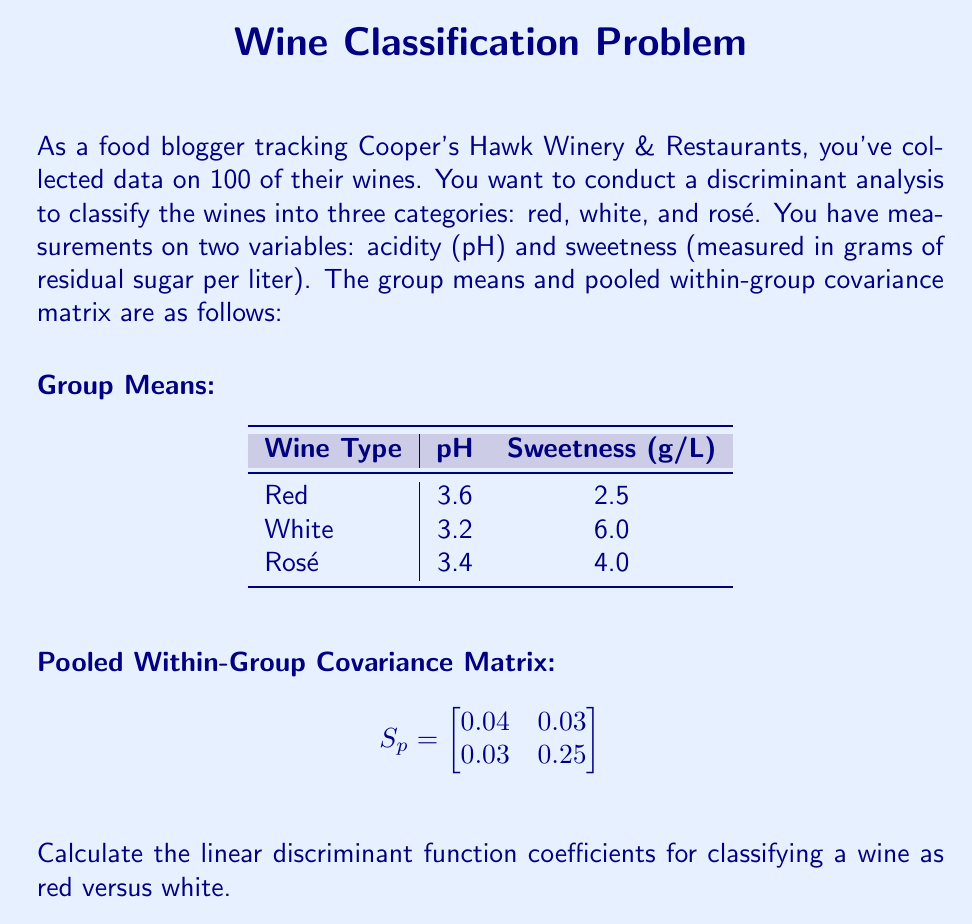Help me with this question. To calculate the linear discriminant function coefficients for red versus white wines, we'll follow these steps:

1) The linear discriminant function has the form:
   $$L = a_1X_1 + a_2X_2 + c$$
   where $X_1$ is pH and $X_2$ is sweetness.

2) The coefficient vector $\mathbf{a} = (a_1, a_2)$ is calculated as:
   $$\mathbf{a} = S_p^{-1}(\bar{\mathbf{x}}_1 - \bar{\mathbf{x}}_2)$$
   where $\bar{\mathbf{x}}_1$ and $\bar{\mathbf{x}}_2$ are the mean vectors for red and white wines respectively.

3) First, let's find $S_p^{-1}$:
   $$S_p^{-1} = \frac{1}{0.04 \cdot 0.25 - 0.03 \cdot 0.03} \begin{bmatrix}
   0.25 & -0.03 \\
   -0.03 & 0.04
   \end{bmatrix} = \begin{bmatrix}
   25.64 & -3.08 \\
   -3.08 & 4.10
   \end{bmatrix}$$

4) Now, let's calculate $(\bar{\mathbf{x}}_1 - \bar{\mathbf{x}}_2)$:
   $$\bar{\mathbf{x}}_1 - \bar{\mathbf{x}}_2 = \begin{pmatrix}
   3.6 \\
   2.5
   \end{pmatrix} - \begin{pmatrix}
   3.2 \\
   6.0
   \end{pmatrix} = \begin{pmatrix}
   0.4 \\
   -3.5
   \end{pmatrix}$$

5) Now we can calculate $\mathbf{a}$:
   $$\mathbf{a} = \begin{bmatrix}
   25.64 & -3.08 \\
   -3.08 & 4.10
   \end{bmatrix} \begin{pmatrix}
   0.4 \\
   -3.5
   \end{pmatrix} = \begin{pmatrix}
   21.04 \\
   -13.57
   \end{pmatrix}$$

6) Therefore, $a_1 = 21.04$ and $a_2 = -13.57$.

The constant term $c$ is not required for the question, but it would be calculated as:
$$c = -\frac{1}{2}(\bar{\mathbf{x}}_1 + \bar{\mathbf{x}}_2)\mathbf{a}$$
Answer: $a_1 = 21.04, a_2 = -13.57$ 